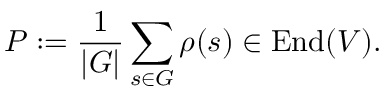<formula> <loc_0><loc_0><loc_500><loc_500>P \colon = { \frac { 1 } { | G | } } \sum _ { s \in G } \rho ( s ) \in { E n d } ( V ) .</formula> 